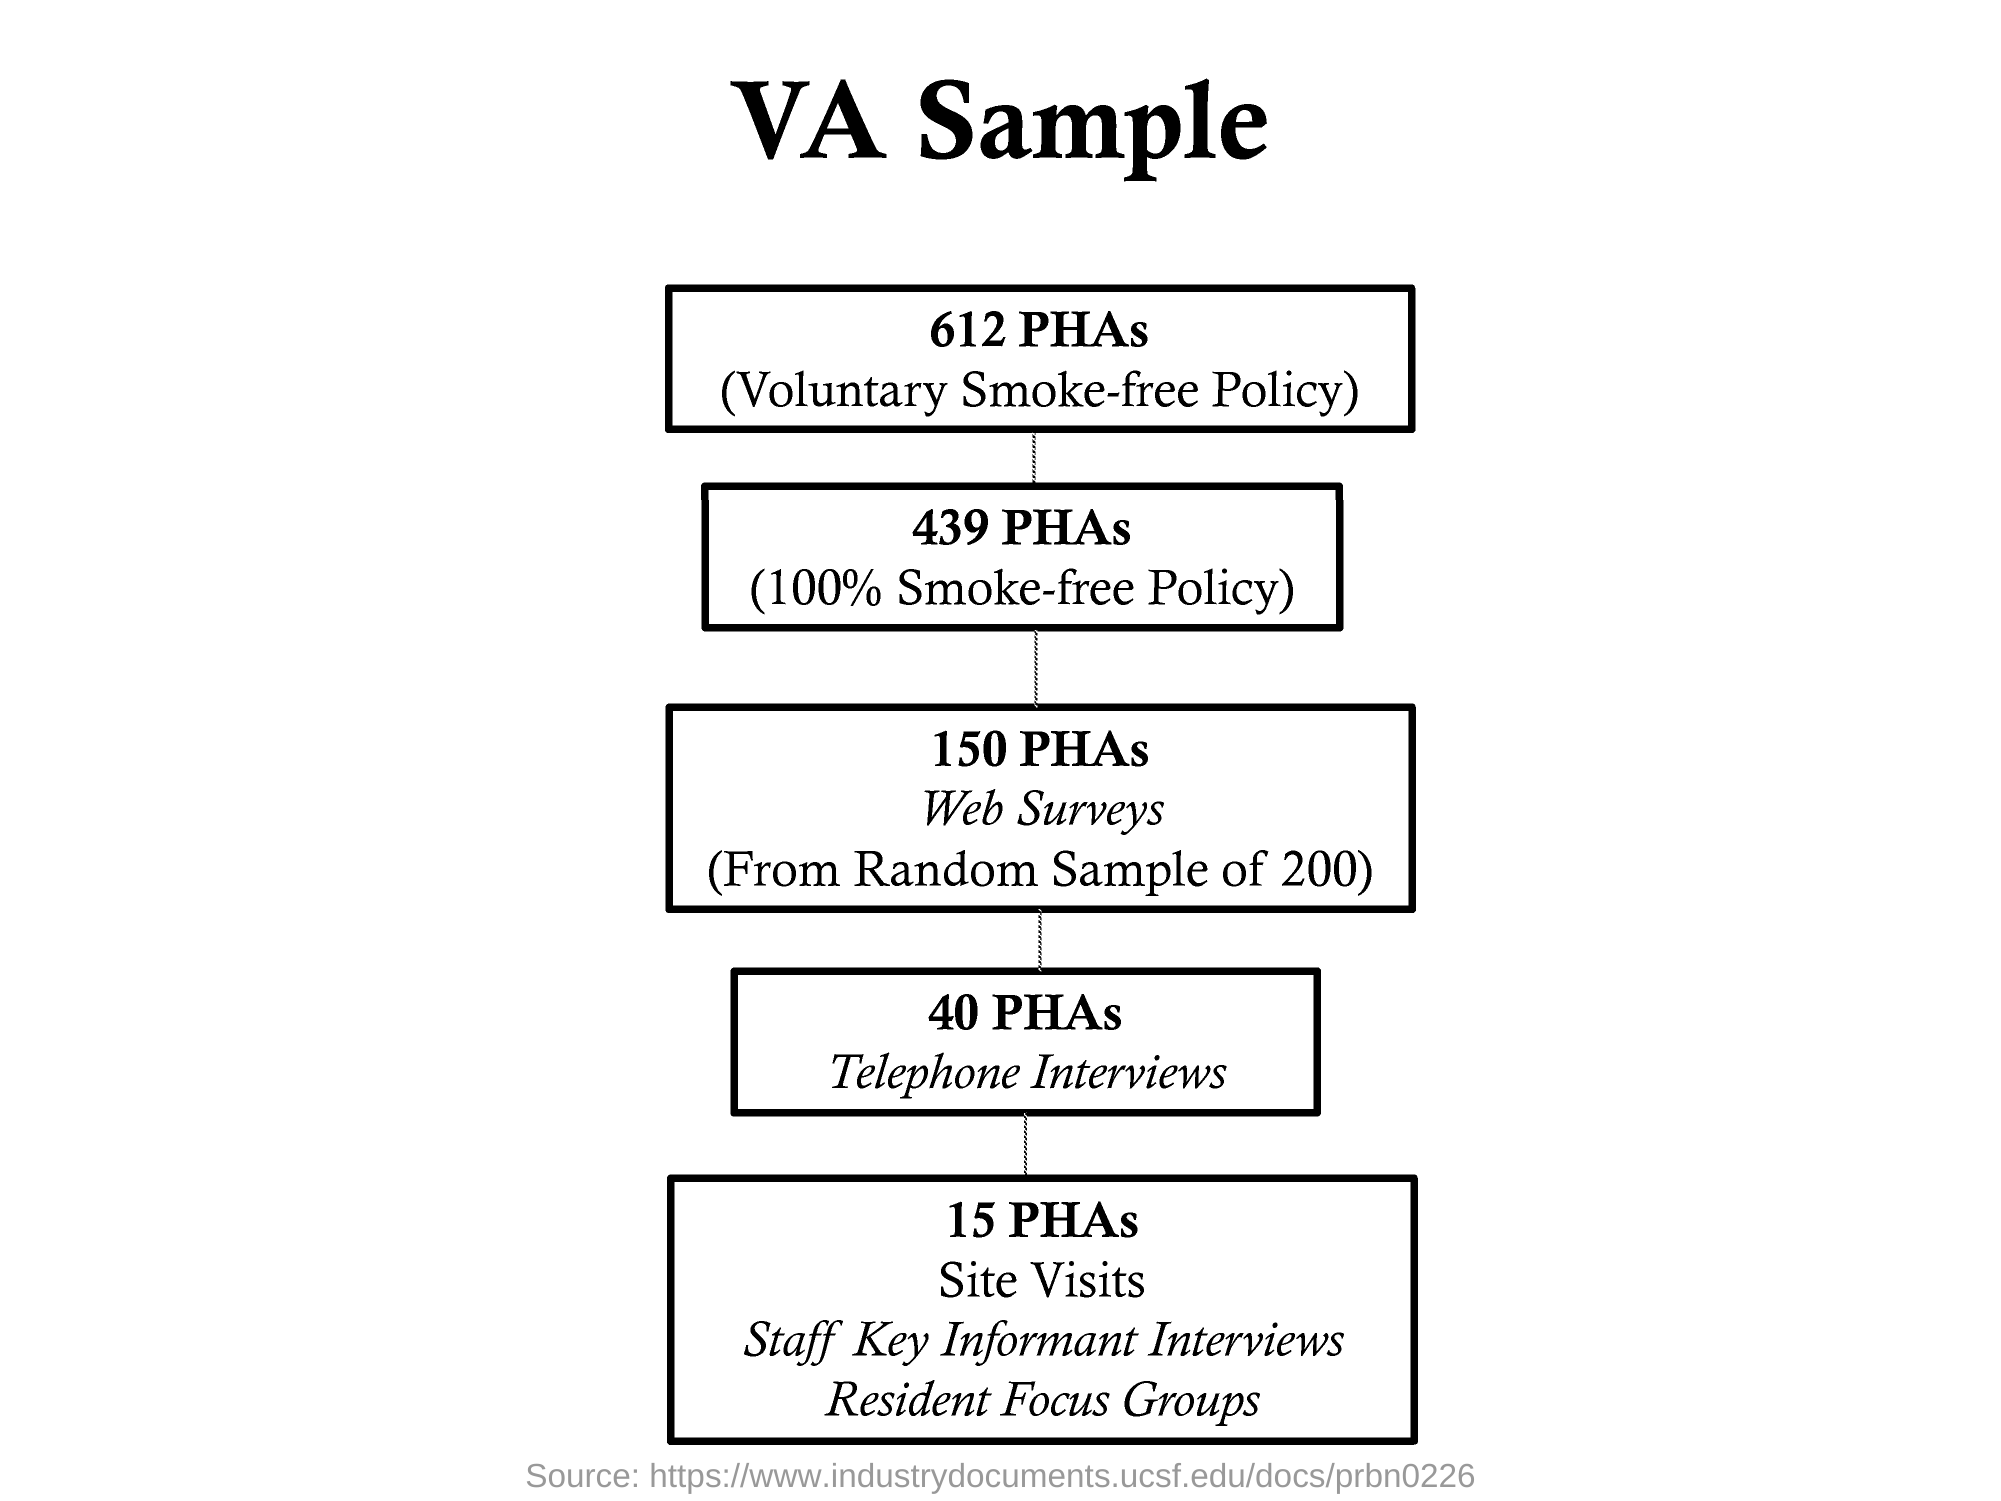Specify some key components in this picture. The number of random samples taken for web surveys is 200. This flowchart is titled 'VA Sample.' 